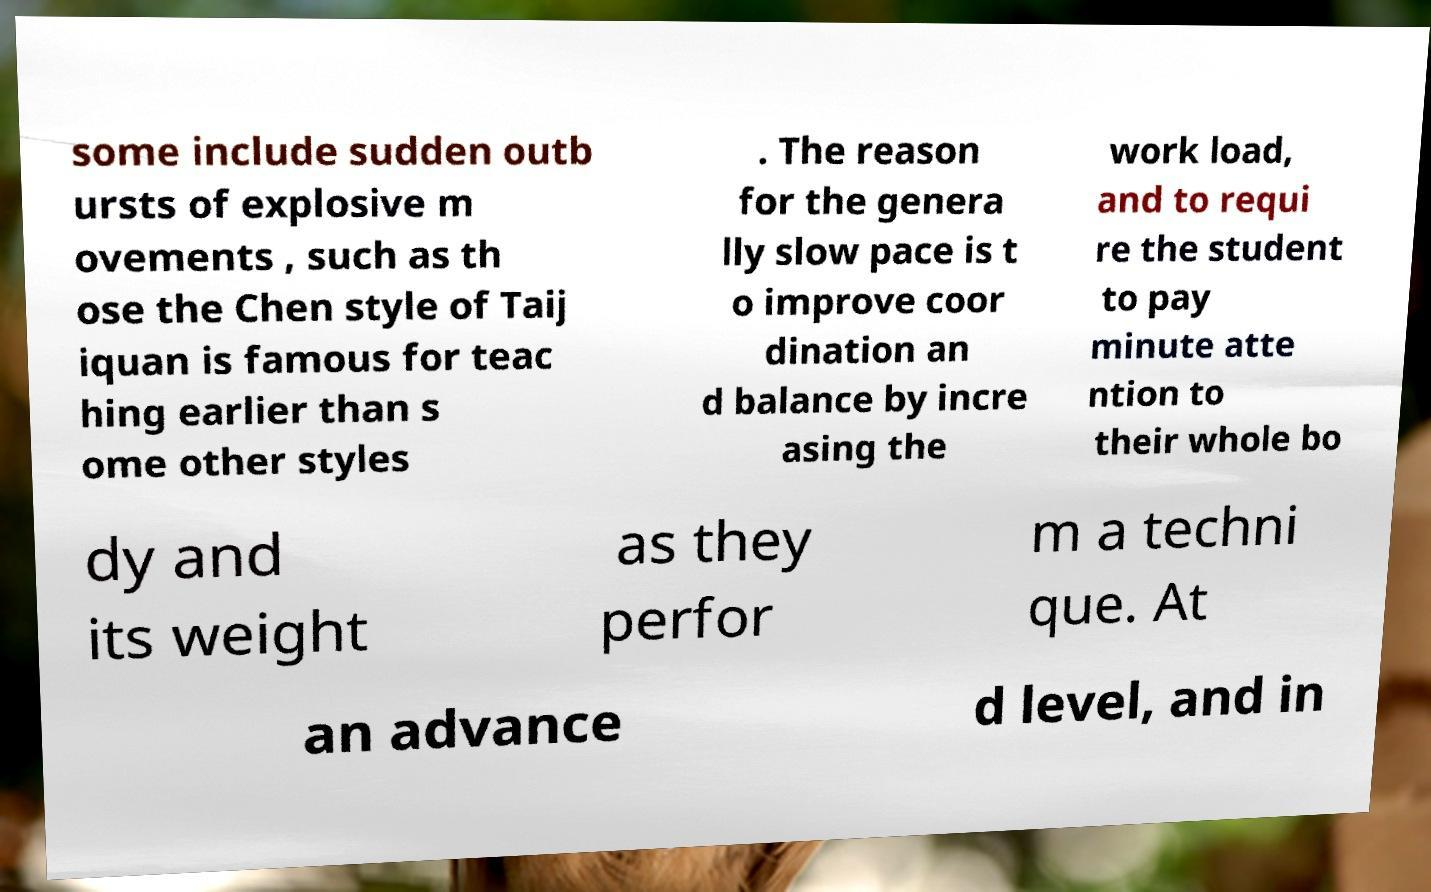Can you read and provide the text displayed in the image?This photo seems to have some interesting text. Can you extract and type it out for me? some include sudden outb ursts of explosive m ovements , such as th ose the Chen style of Taij iquan is famous for teac hing earlier than s ome other styles . The reason for the genera lly slow pace is t o improve coor dination an d balance by incre asing the work load, and to requi re the student to pay minute atte ntion to their whole bo dy and its weight as they perfor m a techni que. At an advance d level, and in 